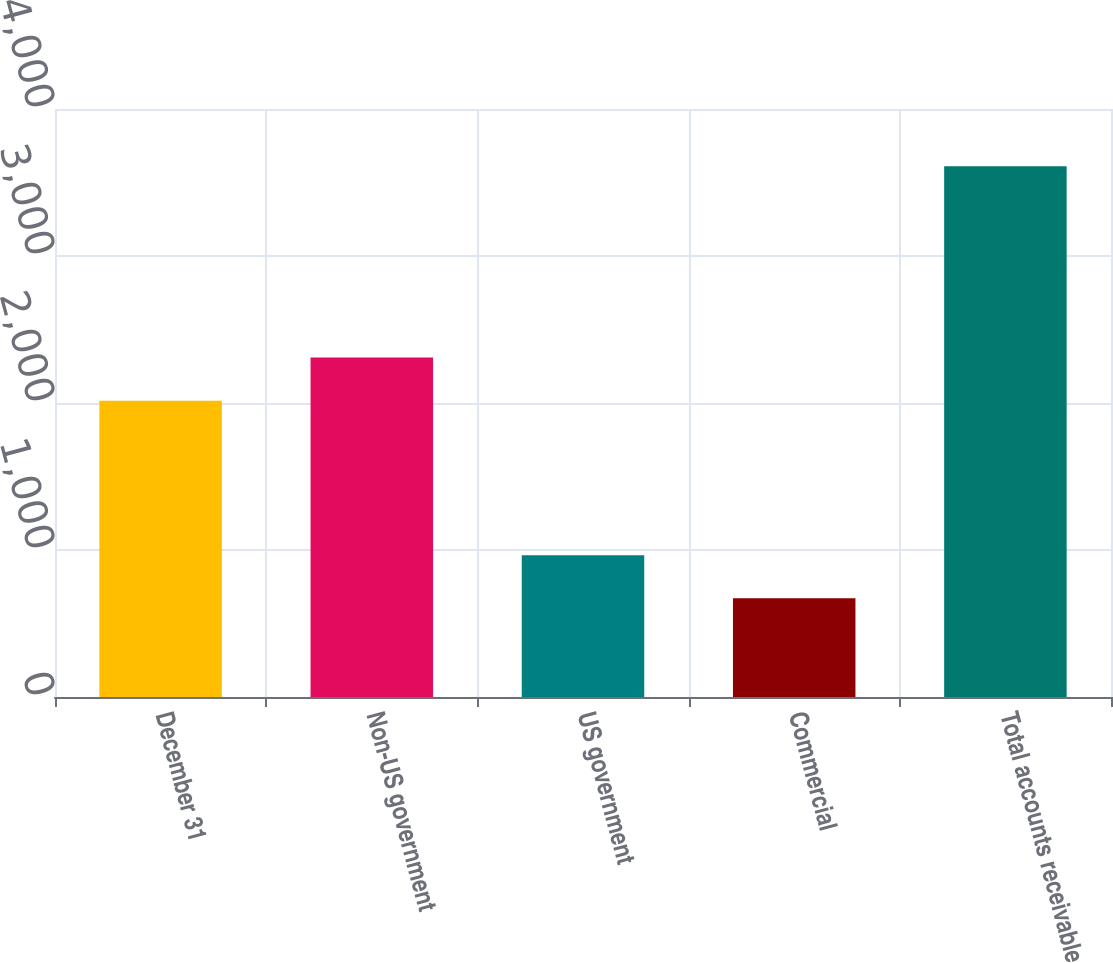Convert chart to OTSL. <chart><loc_0><loc_0><loc_500><loc_500><bar_chart><fcel>December 31<fcel>Non-US government<fcel>US government<fcel>Commercial<fcel>Total accounts receivable<nl><fcel>2016<fcel>2310<fcel>965<fcel>671<fcel>3611<nl></chart> 